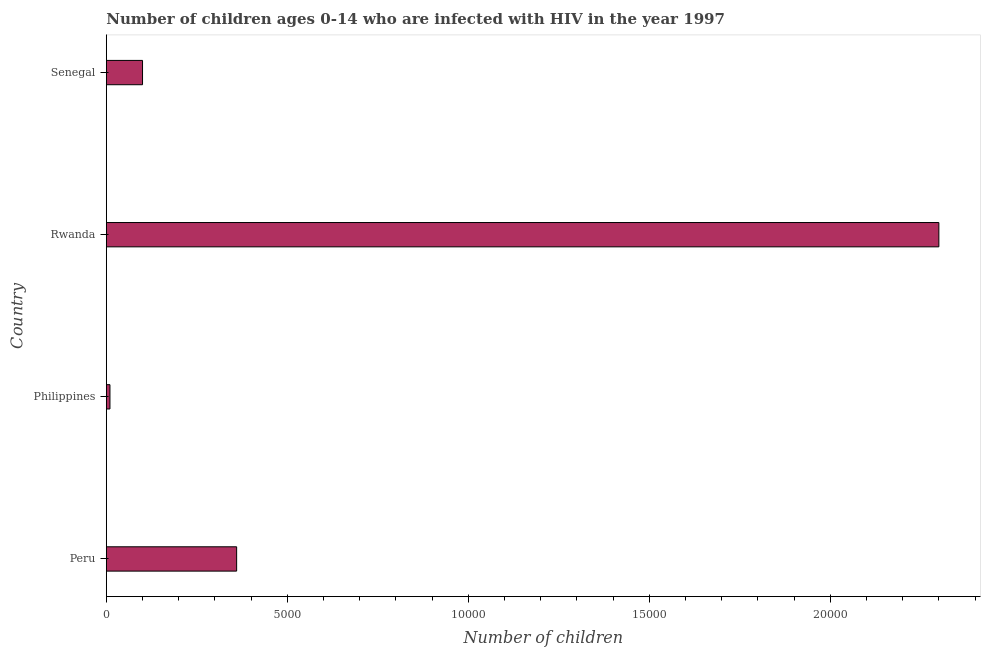Does the graph contain grids?
Provide a succinct answer. No. What is the title of the graph?
Your answer should be compact. Number of children ages 0-14 who are infected with HIV in the year 1997. What is the label or title of the X-axis?
Make the answer very short. Number of children. What is the label or title of the Y-axis?
Offer a very short reply. Country. What is the number of children living with hiv in Rwanda?
Your response must be concise. 2.30e+04. Across all countries, what is the maximum number of children living with hiv?
Provide a short and direct response. 2.30e+04. In which country was the number of children living with hiv maximum?
Your answer should be very brief. Rwanda. In which country was the number of children living with hiv minimum?
Your answer should be compact. Philippines. What is the sum of the number of children living with hiv?
Provide a succinct answer. 2.77e+04. What is the difference between the number of children living with hiv in Peru and Philippines?
Offer a terse response. 3500. What is the average number of children living with hiv per country?
Your response must be concise. 6925. What is the median number of children living with hiv?
Provide a short and direct response. 2300. Is the number of children living with hiv in Peru less than that in Philippines?
Offer a very short reply. No. What is the difference between the highest and the second highest number of children living with hiv?
Make the answer very short. 1.94e+04. What is the difference between the highest and the lowest number of children living with hiv?
Your answer should be very brief. 2.29e+04. How many countries are there in the graph?
Offer a very short reply. 4. What is the difference between two consecutive major ticks on the X-axis?
Your response must be concise. 5000. Are the values on the major ticks of X-axis written in scientific E-notation?
Provide a succinct answer. No. What is the Number of children in Peru?
Your response must be concise. 3600. What is the Number of children in Rwanda?
Your response must be concise. 2.30e+04. What is the difference between the Number of children in Peru and Philippines?
Your answer should be very brief. 3500. What is the difference between the Number of children in Peru and Rwanda?
Provide a succinct answer. -1.94e+04. What is the difference between the Number of children in Peru and Senegal?
Provide a succinct answer. 2600. What is the difference between the Number of children in Philippines and Rwanda?
Provide a short and direct response. -2.29e+04. What is the difference between the Number of children in Philippines and Senegal?
Ensure brevity in your answer.  -900. What is the difference between the Number of children in Rwanda and Senegal?
Your response must be concise. 2.20e+04. What is the ratio of the Number of children in Peru to that in Rwanda?
Your answer should be compact. 0.16. What is the ratio of the Number of children in Peru to that in Senegal?
Provide a succinct answer. 3.6. What is the ratio of the Number of children in Philippines to that in Rwanda?
Provide a short and direct response. 0. 